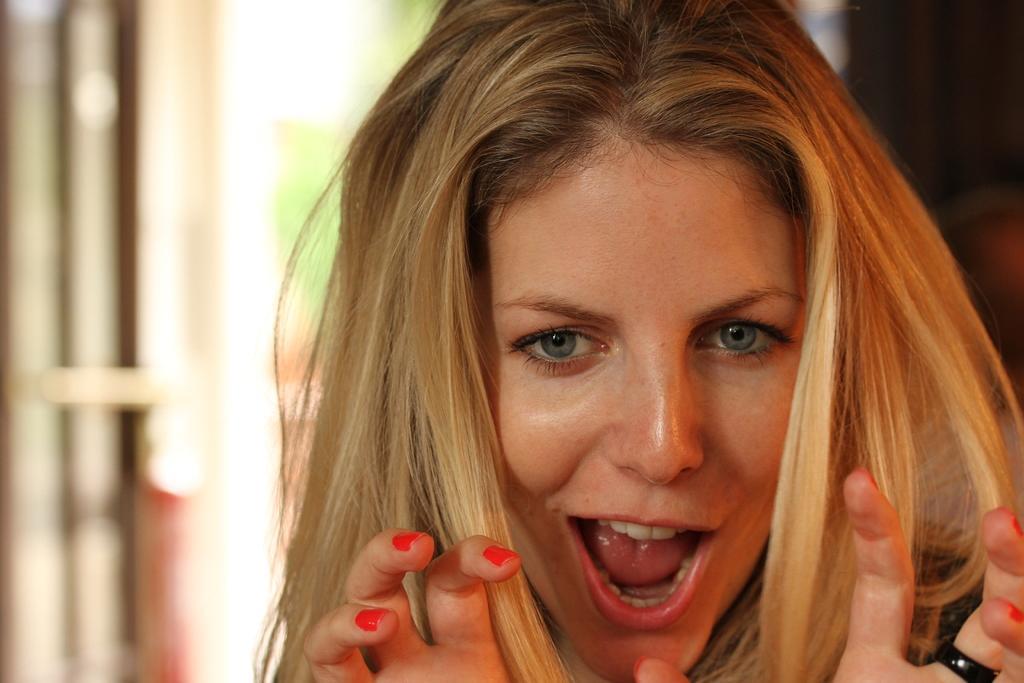How would you summarize this image in a sentence or two? In this picture I can see there is a woman and she is having a ring to her finger and in the backdrop there is a window and the backdrop is blurred. 